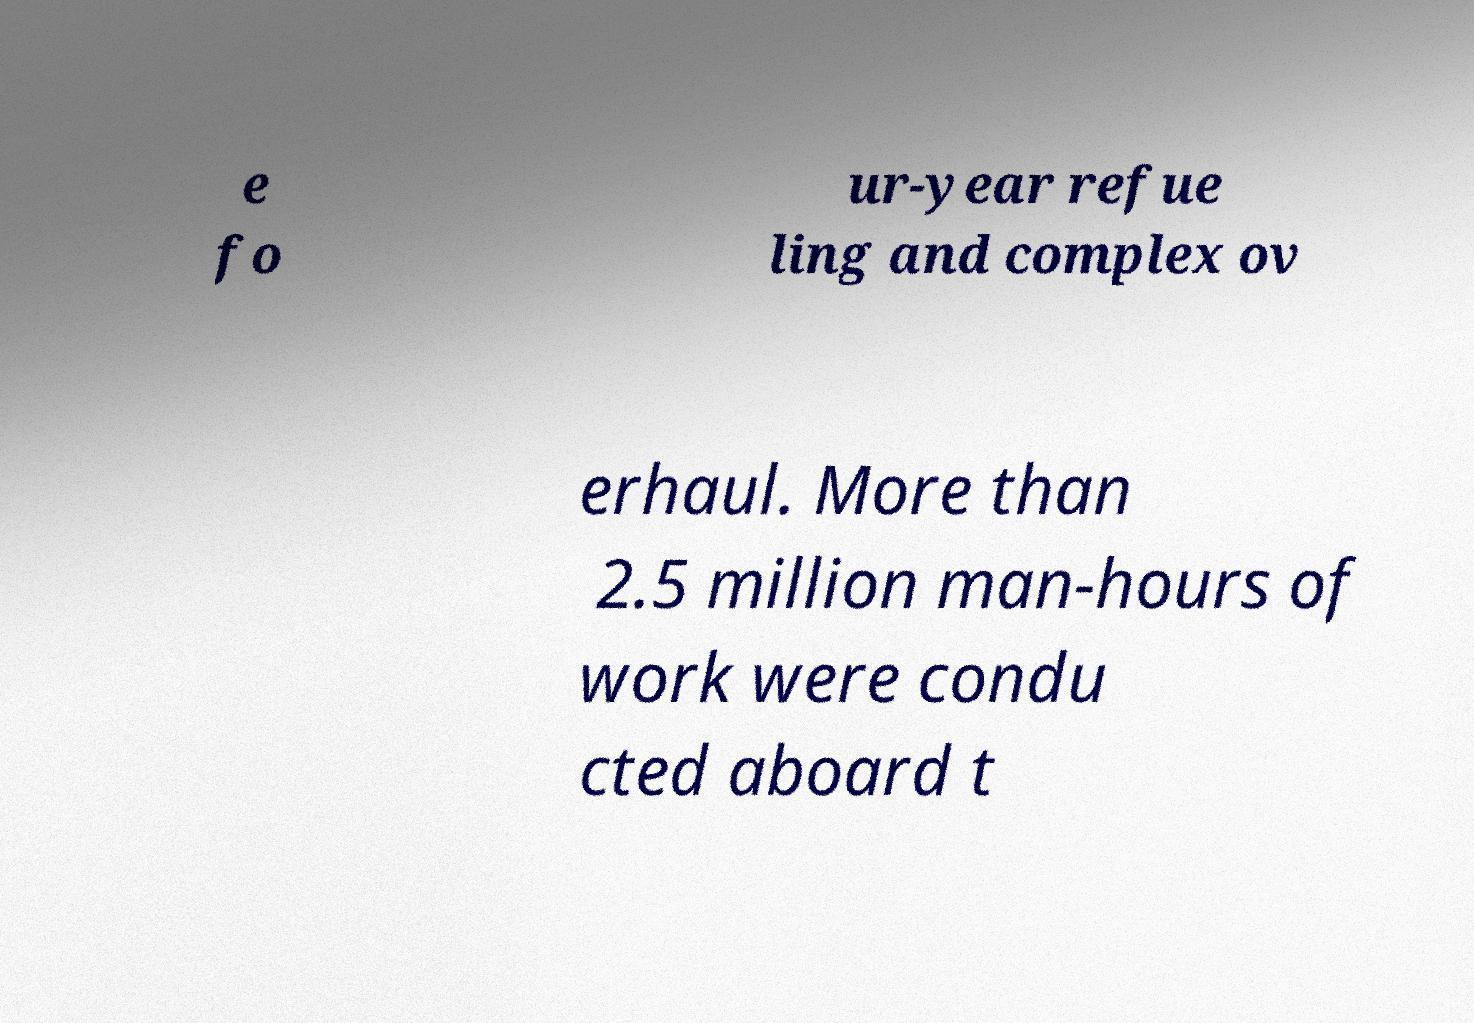There's text embedded in this image that I need extracted. Can you transcribe it verbatim? e fo ur-year refue ling and complex ov erhaul. More than 2.5 million man-hours of work were condu cted aboard t 